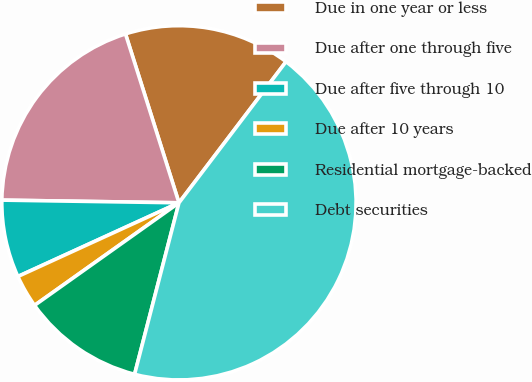<chart> <loc_0><loc_0><loc_500><loc_500><pie_chart><fcel>Due in one year or less<fcel>Due after one through five<fcel>Due after five through 10<fcel>Due after 10 years<fcel>Residential mortgage-backed<fcel>Debt securities<nl><fcel>15.21%<fcel>19.88%<fcel>7.07%<fcel>3.0%<fcel>11.14%<fcel>43.7%<nl></chart> 